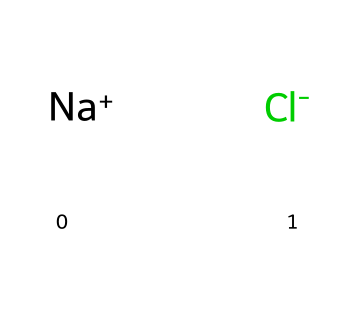What ions are present in this chemical structure? The structure shows sodium (Na+) and chloride (Cl-) ions. The "+" and "-" symbols indicate the charged ions.
Answer: sodium and chloride How many total atoms are in this chemical? There are two atoms: one sodium atom and one chlorine atom, as represented by the two parts of the formula.
Answer: 2 What type of bond exists between the sodium and chloride ions? The sodium ion has a positive charge, and the chloride ion has a negative charge, indicating an ionic bond due to their opposite charges.
Answer: ionic bond What is the primary use of this chemical in aviation? Sodium chloride is commonly used for runway de-icing to lower the freezing point of water and prevent ice formation.
Answer: runway de-icing How does the crystalline structure of this chemical affect its solubility? The ionic nature of the sodium chloride causes it to dissolve well in water, as the water molecules can surround and separate the individual ions.
Answer: high solubility What might happen to the crystalline structure at low temperatures? At low temperatures, the crystalline structure can maintain stability, making sodium chloride effective in icy conditions without loss of integrity.
Answer: stability 